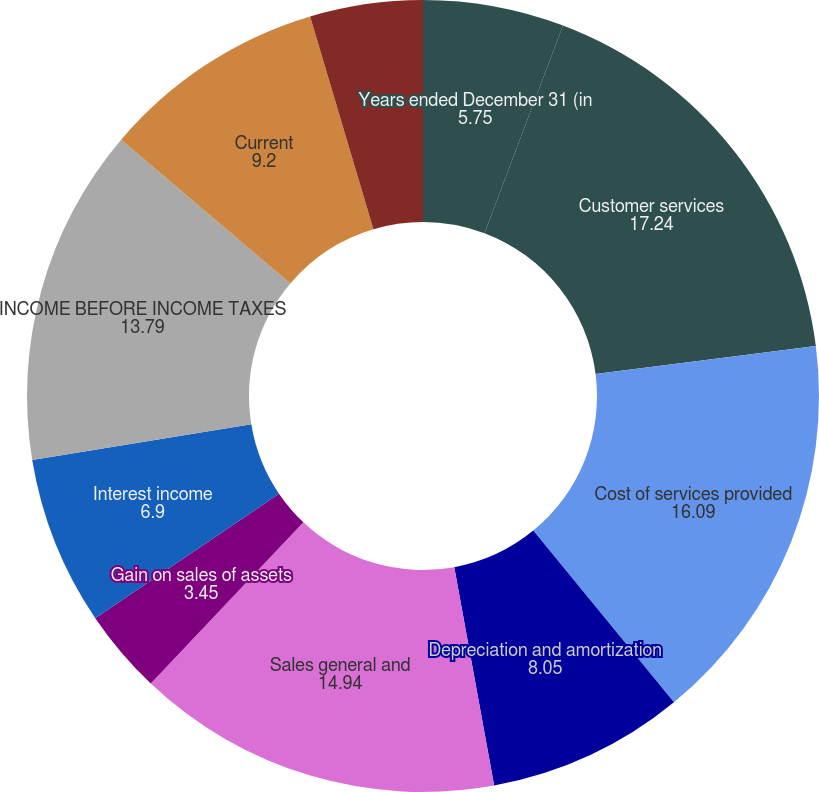Convert chart. <chart><loc_0><loc_0><loc_500><loc_500><pie_chart><fcel>Years ended December 31 (in<fcel>Customer services<fcel>Cost of services provided<fcel>Depreciation and amortization<fcel>Sales general and<fcel>Gain on sales of assets<fcel>Interest income<fcel>INCOME BEFORE INCOME TAXES<fcel>Current<fcel>Deferred<nl><fcel>5.75%<fcel>17.24%<fcel>16.09%<fcel>8.05%<fcel>14.94%<fcel>3.45%<fcel>6.9%<fcel>13.79%<fcel>9.2%<fcel>4.6%<nl></chart> 